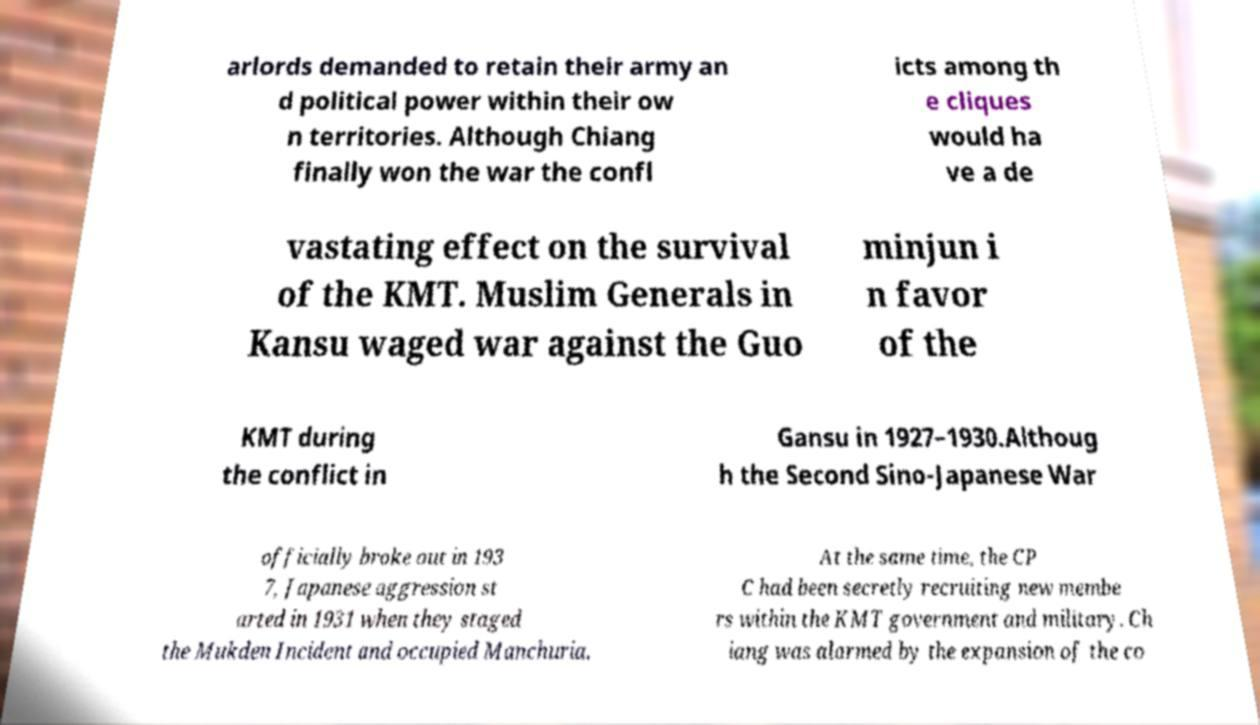Please read and relay the text visible in this image. What does it say? arlords demanded to retain their army an d political power within their ow n territories. Although Chiang finally won the war the confl icts among th e cliques would ha ve a de vastating effect on the survival of the KMT. Muslim Generals in Kansu waged war against the Guo minjun i n favor of the KMT during the conflict in Gansu in 1927–1930.Althoug h the Second Sino-Japanese War officially broke out in 193 7, Japanese aggression st arted in 1931 when they staged the Mukden Incident and occupied Manchuria. At the same time, the CP C had been secretly recruiting new membe rs within the KMT government and military. Ch iang was alarmed by the expansion of the co 